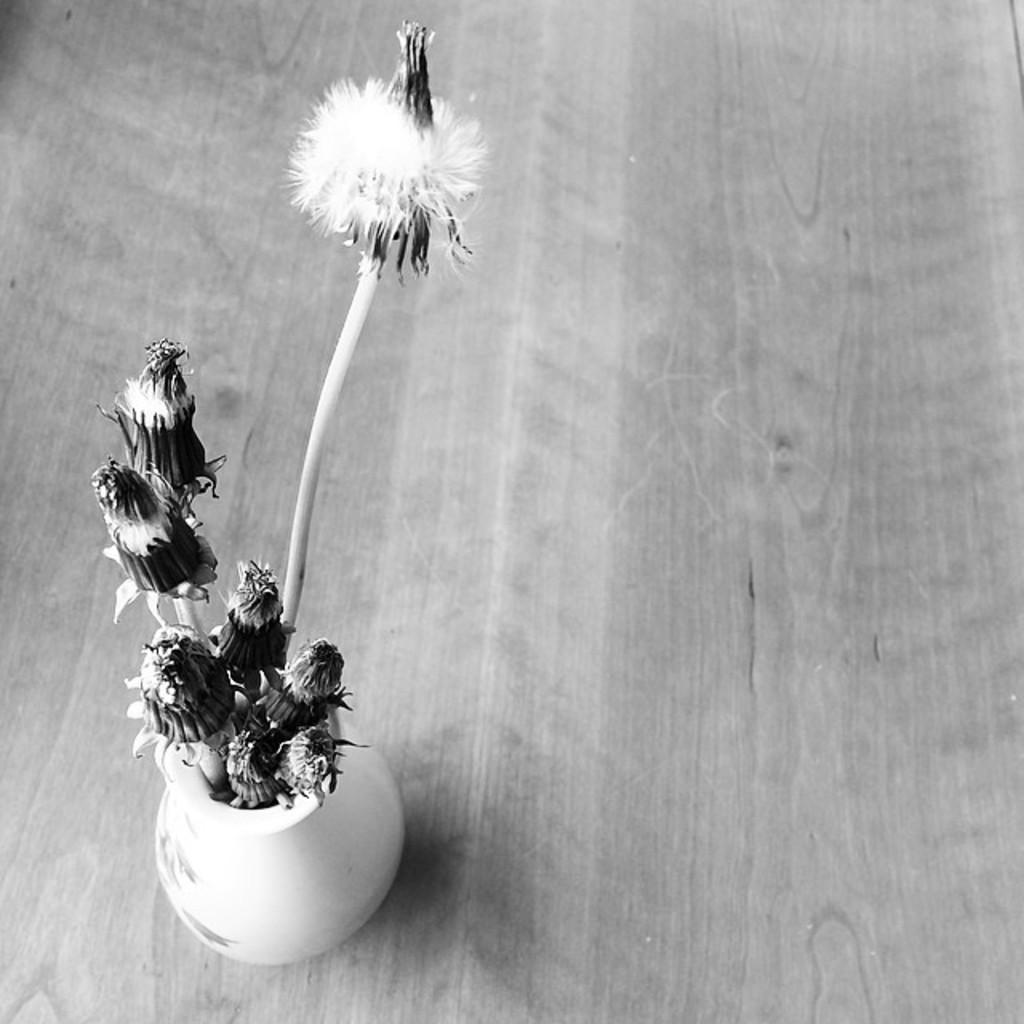What is the main object in the picture? There is a flower vase in the picture. What is inside the vase? The vase has flowers in it. On what surface is the vase placed? The flower vase is placed on a wooden table. What type of science experiment is being conducted with the flowers in the vase? There is no indication of a science experiment in the image; it simply shows a flower vase with flowers in it. 